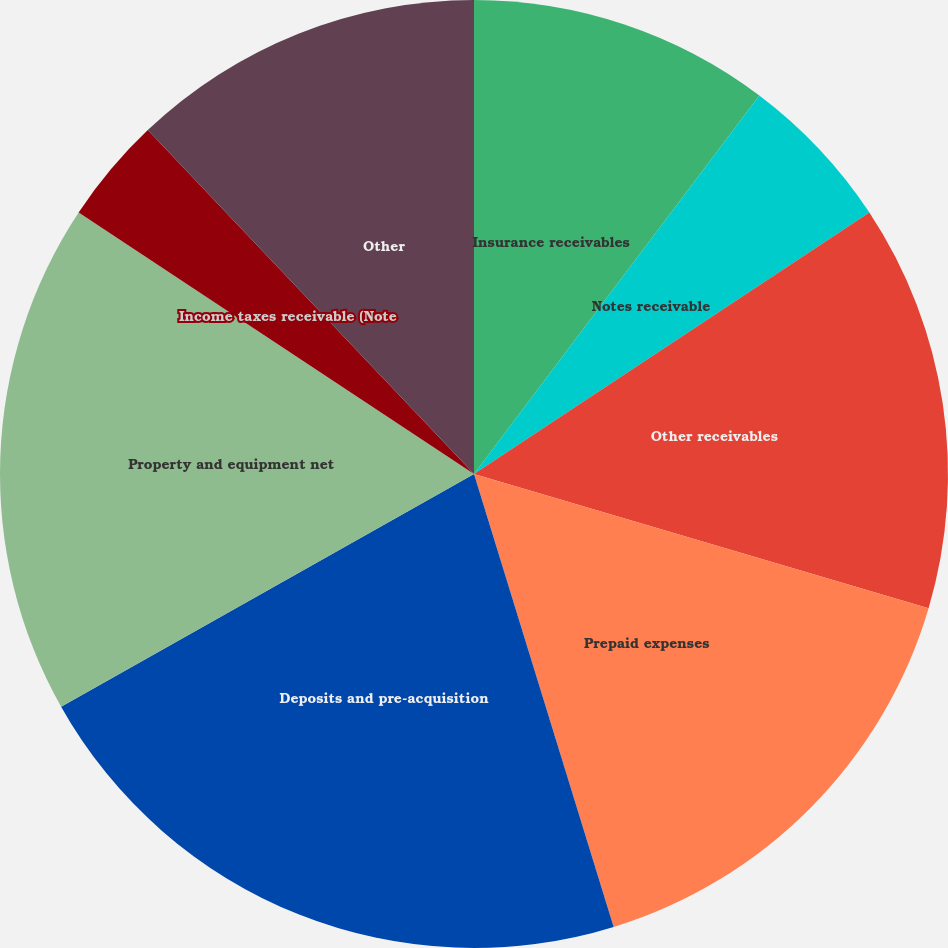Convert chart. <chart><loc_0><loc_0><loc_500><loc_500><pie_chart><fcel>Insurance receivables<fcel>Notes receivable<fcel>Other receivables<fcel>Prepaid expenses<fcel>Deposits and pre-acquisition<fcel>Property and equipment net<fcel>Income taxes receivable (Note<fcel>Other<nl><fcel>10.28%<fcel>5.42%<fcel>13.87%<fcel>15.67%<fcel>21.59%<fcel>17.47%<fcel>3.62%<fcel>12.08%<nl></chart> 